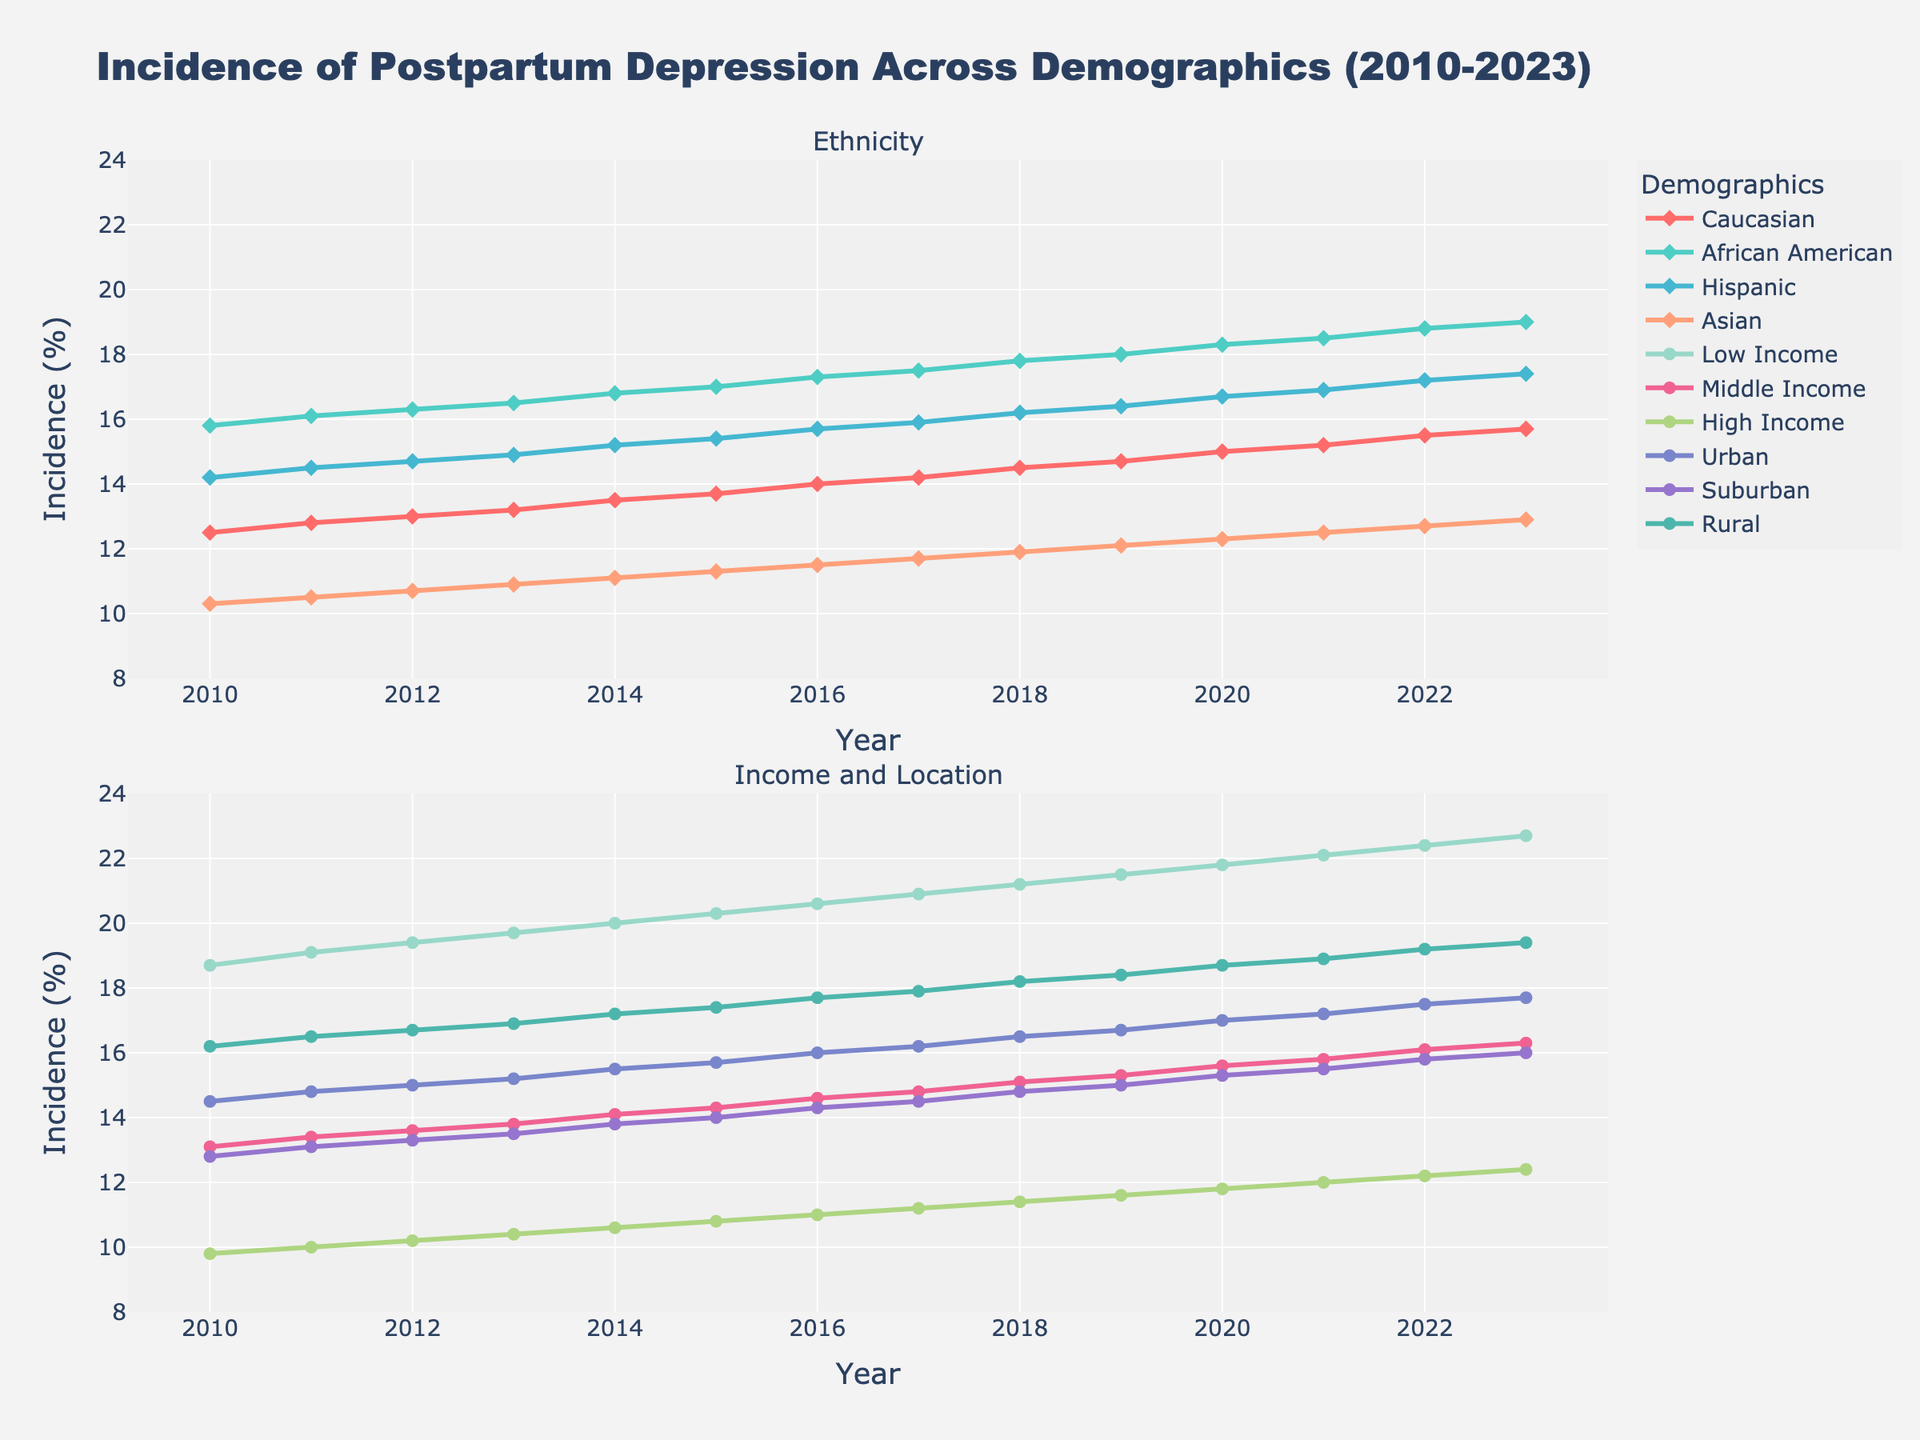What is the overall trend of postpartum depression incidence among Caucasians from 2010 to 2023? The figure shows a steady increase in the incidence of postpartum depression among Caucasians from 12.5% in 2010 to 15.7% in 2023. Following the trend line, we can observe a gradual upward movement across the years.
Answer: Steady increase Which ethnic group has the highest incidence of postpartum depression in 2023? To find the ethnic group with the highest incidence in 2023, we compare the values for Caucasian, African American, Hispanic, and Asian groups. The African American group has the highest incidence at 19.0%.
Answer: African American How much did the incidence of postpartum depression change among the Low Income group from 2010 to 2023? The incidence among the Low Income group was 18.7% in 2010 and increased to 22.7% in 2023. The change is calculated as 22.7% - 18.7% = 4.0%.
Answer: 4.0% Which location type (Urban, Suburban, Rural) showed the highest increase in postpartum depression incidence over the period 2010 to 2023? We look at the incidence values for Urban, Suburban, and Rural for 2010 and 2023. Urban incidence increased from 14.5% to 17.7% (3.2%), Suburban from 12.8% to 16.0% (3.2%), and Rural from 16.2% to 19.4% (3.2%), showing that all three location types had the same increase.
Answer: All had equal increases What is the difference in postpartum depression incidence between African American and Asian women in 2022? In 2022, the incidence for African American women was 18.8% and for Asian women was 12.7%. The difference is 18.8% - 12.7% = 6.1%.
Answer: 6.1% Which demographic had the lowest incidence of postpartum depression in 2023 and what was the value? By comparing the incidence values for all demographics in 2023, the High Income group had the lowest incidence at 12.4%.
Answer: High Income, 12.4% Is the trend of postpartum depression incidence among Hispanic women increasing, decreasing, or stable from 2010 to 2023? The incidence among Hispanic women increases from 14.2% in 2010 to 17.4% in 2023, reflecting an upward trend over the years.
Answer: Increasing What are the median values of incidence for the Rural and Suburban groups across the timeline 2010 to 2023? To find the median values, list each year's incidence percentages for both groups and determine the middle values. For Rural: (16.2, 16.5, 16.7, 16.9, 17.2, 17.4, 17.7, 17.9, 18.2, 18.4, 18.7, 18.9, 19.2, 19.4) the median is 17.75%. For Suburban: (12.8, 13.1, 13.3, 13.5, 13.8, 14.0, 14.3, 14.5, 14.8, 15.0, 15.3, 15.5, 15.8, 16.0) the median is 14.45%.
Answer: Rural: 17.75%, Suburban: 14.45% 